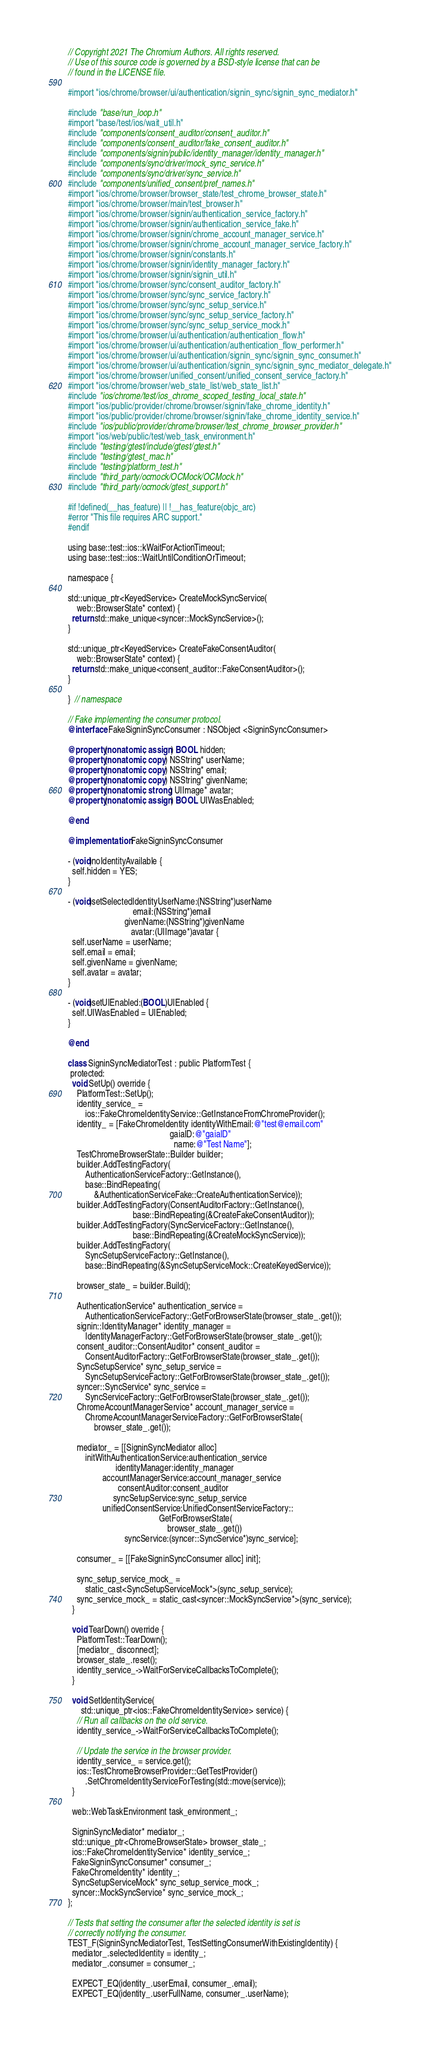<code> <loc_0><loc_0><loc_500><loc_500><_ObjectiveC_>// Copyright 2021 The Chromium Authors. All rights reserved.
// Use of this source code is governed by a BSD-style license that can be
// found in the LICENSE file.

#import "ios/chrome/browser/ui/authentication/signin_sync/signin_sync_mediator.h"

#include "base/run_loop.h"
#import "base/test/ios/wait_util.h"
#include "components/consent_auditor/consent_auditor.h"
#include "components/consent_auditor/fake_consent_auditor.h"
#include "components/signin/public/identity_manager/identity_manager.h"
#include "components/sync/driver/mock_sync_service.h"
#include "components/sync/driver/sync_service.h"
#include "components/unified_consent/pref_names.h"
#import "ios/chrome/browser/browser_state/test_chrome_browser_state.h"
#import "ios/chrome/browser/main/test_browser.h"
#import "ios/chrome/browser/signin/authentication_service_factory.h"
#import "ios/chrome/browser/signin/authentication_service_fake.h"
#import "ios/chrome/browser/signin/chrome_account_manager_service.h"
#import "ios/chrome/browser/signin/chrome_account_manager_service_factory.h"
#import "ios/chrome/browser/signin/constants.h"
#import "ios/chrome/browser/signin/identity_manager_factory.h"
#import "ios/chrome/browser/signin/signin_util.h"
#import "ios/chrome/browser/sync/consent_auditor_factory.h"
#import "ios/chrome/browser/sync/sync_service_factory.h"
#import "ios/chrome/browser/sync/sync_setup_service.h"
#import "ios/chrome/browser/sync/sync_setup_service_factory.h"
#import "ios/chrome/browser/sync/sync_setup_service_mock.h"
#import "ios/chrome/browser/ui/authentication/authentication_flow.h"
#import "ios/chrome/browser/ui/authentication/authentication_flow_performer.h"
#import "ios/chrome/browser/ui/authentication/signin_sync/signin_sync_consumer.h"
#import "ios/chrome/browser/ui/authentication/signin_sync/signin_sync_mediator_delegate.h"
#import "ios/chrome/browser/unified_consent/unified_consent_service_factory.h"
#import "ios/chrome/browser/web_state_list/web_state_list.h"
#include "ios/chrome/test/ios_chrome_scoped_testing_local_state.h"
#import "ios/public/provider/chrome/browser/signin/fake_chrome_identity.h"
#import "ios/public/provider/chrome/browser/signin/fake_chrome_identity_service.h"
#include "ios/public/provider/chrome/browser/test_chrome_browser_provider.h"
#import "ios/web/public/test/web_task_environment.h"
#include "testing/gtest/include/gtest/gtest.h"
#include "testing/gtest_mac.h"
#include "testing/platform_test.h"
#include "third_party/ocmock/OCMock/OCMock.h"
#include "third_party/ocmock/gtest_support.h"

#if !defined(__has_feature) || !__has_feature(objc_arc)
#error "This file requires ARC support."
#endif

using base::test::ios::kWaitForActionTimeout;
using base::test::ios::WaitUntilConditionOrTimeout;

namespace {

std::unique_ptr<KeyedService> CreateMockSyncService(
    web::BrowserState* context) {
  return std::make_unique<syncer::MockSyncService>();
}

std::unique_ptr<KeyedService> CreateFakeConsentAuditor(
    web::BrowserState* context) {
  return std::make_unique<consent_auditor::FakeConsentAuditor>();
}

}  // namespace

// Fake implementing the consumer protocol.
@interface FakeSigninSyncConsumer : NSObject <SigninSyncConsumer>

@property(nonatomic, assign) BOOL hidden;
@property(nonatomic, copy) NSString* userName;
@property(nonatomic, copy) NSString* email;
@property(nonatomic, copy) NSString* givenName;
@property(nonatomic, strong) UIImage* avatar;
@property(nonatomic, assign) BOOL UIWasEnabled;

@end

@implementation FakeSigninSyncConsumer

- (void)noIdentityAvailable {
  self.hidden = YES;
}

- (void)setSelectedIdentityUserName:(NSString*)userName
                              email:(NSString*)email
                          givenName:(NSString*)givenName
                             avatar:(UIImage*)avatar {
  self.userName = userName;
  self.email = email;
  self.givenName = givenName;
  self.avatar = avatar;
}

- (void)setUIEnabled:(BOOL)UIEnabled {
  self.UIWasEnabled = UIEnabled;
}

@end

class SigninSyncMediatorTest : public PlatformTest {
 protected:
  void SetUp() override {
    PlatformTest::SetUp();
    identity_service_ =
        ios::FakeChromeIdentityService::GetInstanceFromChromeProvider();
    identity_ = [FakeChromeIdentity identityWithEmail:@"test@email.com"
                                               gaiaID:@"gaiaID"
                                                 name:@"Test Name"];
    TestChromeBrowserState::Builder builder;
    builder.AddTestingFactory(
        AuthenticationServiceFactory::GetInstance(),
        base::BindRepeating(
            &AuthenticationServiceFake::CreateAuthenticationService));
    builder.AddTestingFactory(ConsentAuditorFactory::GetInstance(),
                              base::BindRepeating(&CreateFakeConsentAuditor));
    builder.AddTestingFactory(SyncServiceFactory::GetInstance(),
                              base::BindRepeating(&CreateMockSyncService));
    builder.AddTestingFactory(
        SyncSetupServiceFactory::GetInstance(),
        base::BindRepeating(&SyncSetupServiceMock::CreateKeyedService));

    browser_state_ = builder.Build();

    AuthenticationService* authentication_service =
        AuthenticationServiceFactory::GetForBrowserState(browser_state_.get());
    signin::IdentityManager* identity_manager =
        IdentityManagerFactory::GetForBrowserState(browser_state_.get());
    consent_auditor::ConsentAuditor* consent_auditor =
        ConsentAuditorFactory::GetForBrowserState(browser_state_.get());
    SyncSetupService* sync_setup_service =
        SyncSetupServiceFactory::GetForBrowserState(browser_state_.get());
    syncer::SyncService* sync_service =
        SyncServiceFactory::GetForBrowserState(browser_state_.get());
    ChromeAccountManagerService* account_manager_service =
        ChromeAccountManagerServiceFactory::GetForBrowserState(
            browser_state_.get());

    mediator_ = [[SigninSyncMediator alloc]
        initWithAuthenticationService:authentication_service
                      identityManager:identity_manager
                accountManagerService:account_manager_service
                       consentAuditor:consent_auditor
                     syncSetupService:sync_setup_service
                unifiedConsentService:UnifiedConsentServiceFactory::
                                          GetForBrowserState(
                                              browser_state_.get())
                          syncService:(syncer::SyncService*)sync_service];

    consumer_ = [[FakeSigninSyncConsumer alloc] init];

    sync_setup_service_mock_ =
        static_cast<SyncSetupServiceMock*>(sync_setup_service);
    sync_service_mock_ = static_cast<syncer::MockSyncService*>(sync_service);
  }

  void TearDown() override {
    PlatformTest::TearDown();
    [mediator_ disconnect];
    browser_state_.reset();
    identity_service_->WaitForServiceCallbacksToComplete();
  }

  void SetIdentityService(
      std::unique_ptr<ios::FakeChromeIdentityService> service) {
    // Run all callbacks on the old service.
    identity_service_->WaitForServiceCallbacksToComplete();

    // Update the service in the browser provider.
    identity_service_ = service.get();
    ios::TestChromeBrowserProvider::GetTestProvider()
        .SetChromeIdentityServiceForTesting(std::move(service));
  }

  web::WebTaskEnvironment task_environment_;

  SigninSyncMediator* mediator_;
  std::unique_ptr<ChromeBrowserState> browser_state_;
  ios::FakeChromeIdentityService* identity_service_;
  FakeSigninSyncConsumer* consumer_;
  FakeChromeIdentity* identity_;
  SyncSetupServiceMock* sync_setup_service_mock_;
  syncer::MockSyncService* sync_service_mock_;
};

// Tests that setting the consumer after the selected identity is set is
// correctly notifying the consumer.
TEST_F(SigninSyncMediatorTest, TestSettingConsumerWithExistingIdentity) {
  mediator_.selectedIdentity = identity_;
  mediator_.consumer = consumer_;

  EXPECT_EQ(identity_.userEmail, consumer_.email);
  EXPECT_EQ(identity_.userFullName, consumer_.userName);</code> 